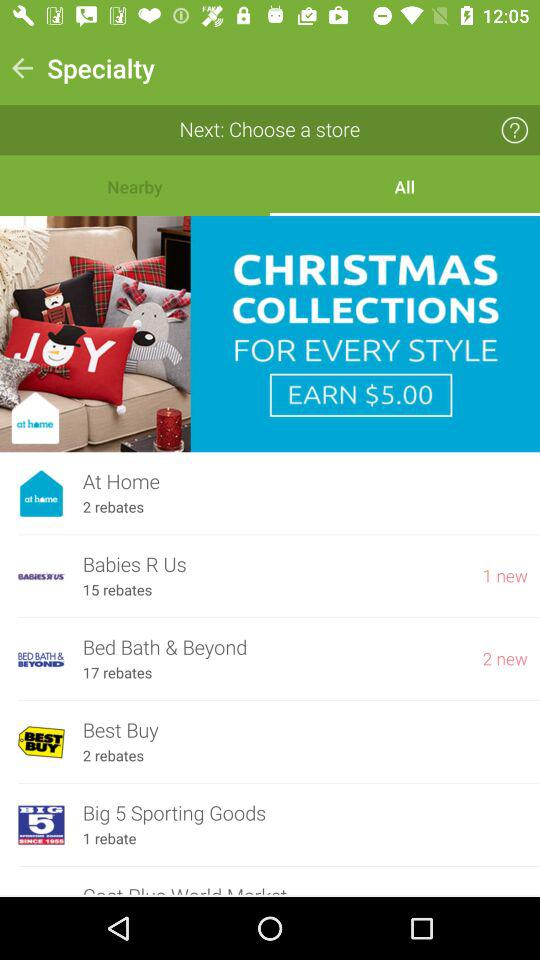How many rebates are there in "At Home"? There are 2 rebates in "At Home". 